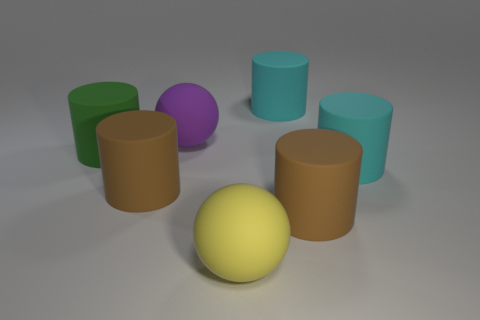Add 3 big brown cylinders. How many objects exist? 10 Subtract all cylinders. How many objects are left? 2 Subtract all large things. Subtract all blue metal cylinders. How many objects are left? 0 Add 4 big matte spheres. How many big matte spheres are left? 6 Add 1 brown rubber cylinders. How many brown rubber cylinders exist? 3 Subtract 1 purple balls. How many objects are left? 6 